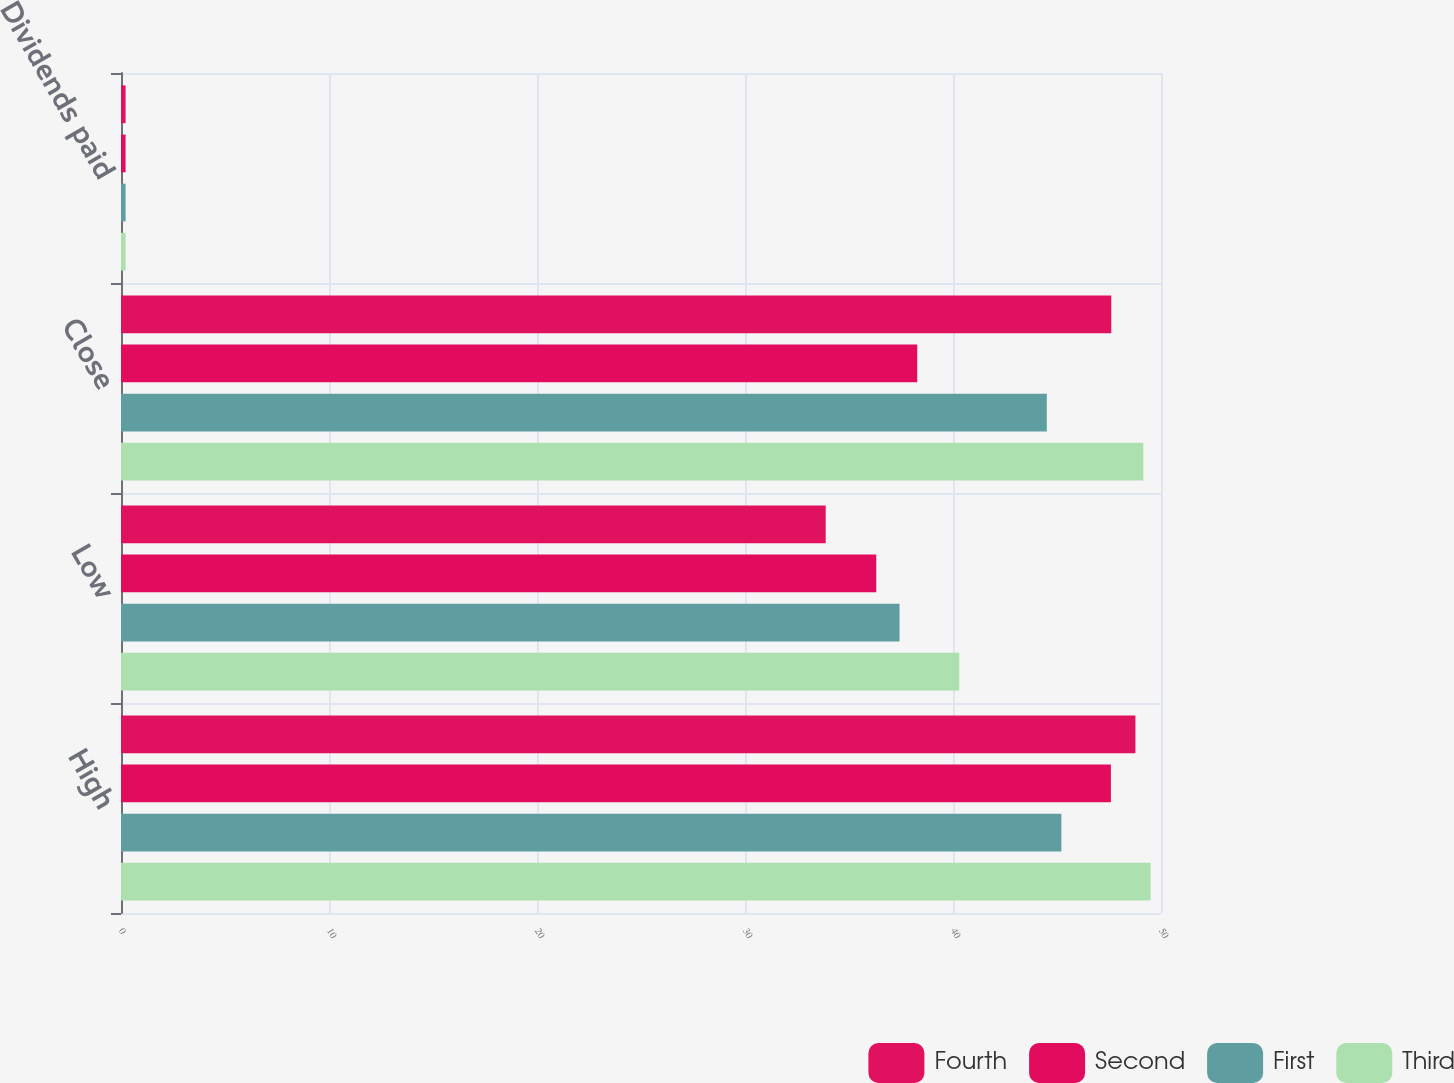Convert chart. <chart><loc_0><loc_0><loc_500><loc_500><stacked_bar_chart><ecel><fcel>High<fcel>Low<fcel>Close<fcel>Dividends paid<nl><fcel>Fourth<fcel>48.77<fcel>33.88<fcel>47.61<fcel>0.22<nl><fcel>Second<fcel>47.59<fcel>36.31<fcel>38.28<fcel>0.22<nl><fcel>First<fcel>45.21<fcel>37.43<fcel>44.51<fcel>0.22<nl><fcel>Third<fcel>49.5<fcel>40.3<fcel>49.15<fcel>0.22<nl></chart> 